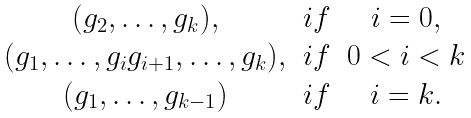Convert formula to latex. <formula><loc_0><loc_0><loc_500><loc_500>\begin{matrix} ( g _ { 2 } , \dots , g _ { k } ) , & i f & i = 0 , \\ ( g _ { 1 } , \dots , g _ { i } g _ { i + 1 } , \dots , g _ { k } ) , & i f & 0 < i < k \\ ( g _ { 1 } , \dots , g _ { k - 1 } ) & i f & i = k . \end{matrix}</formula> 